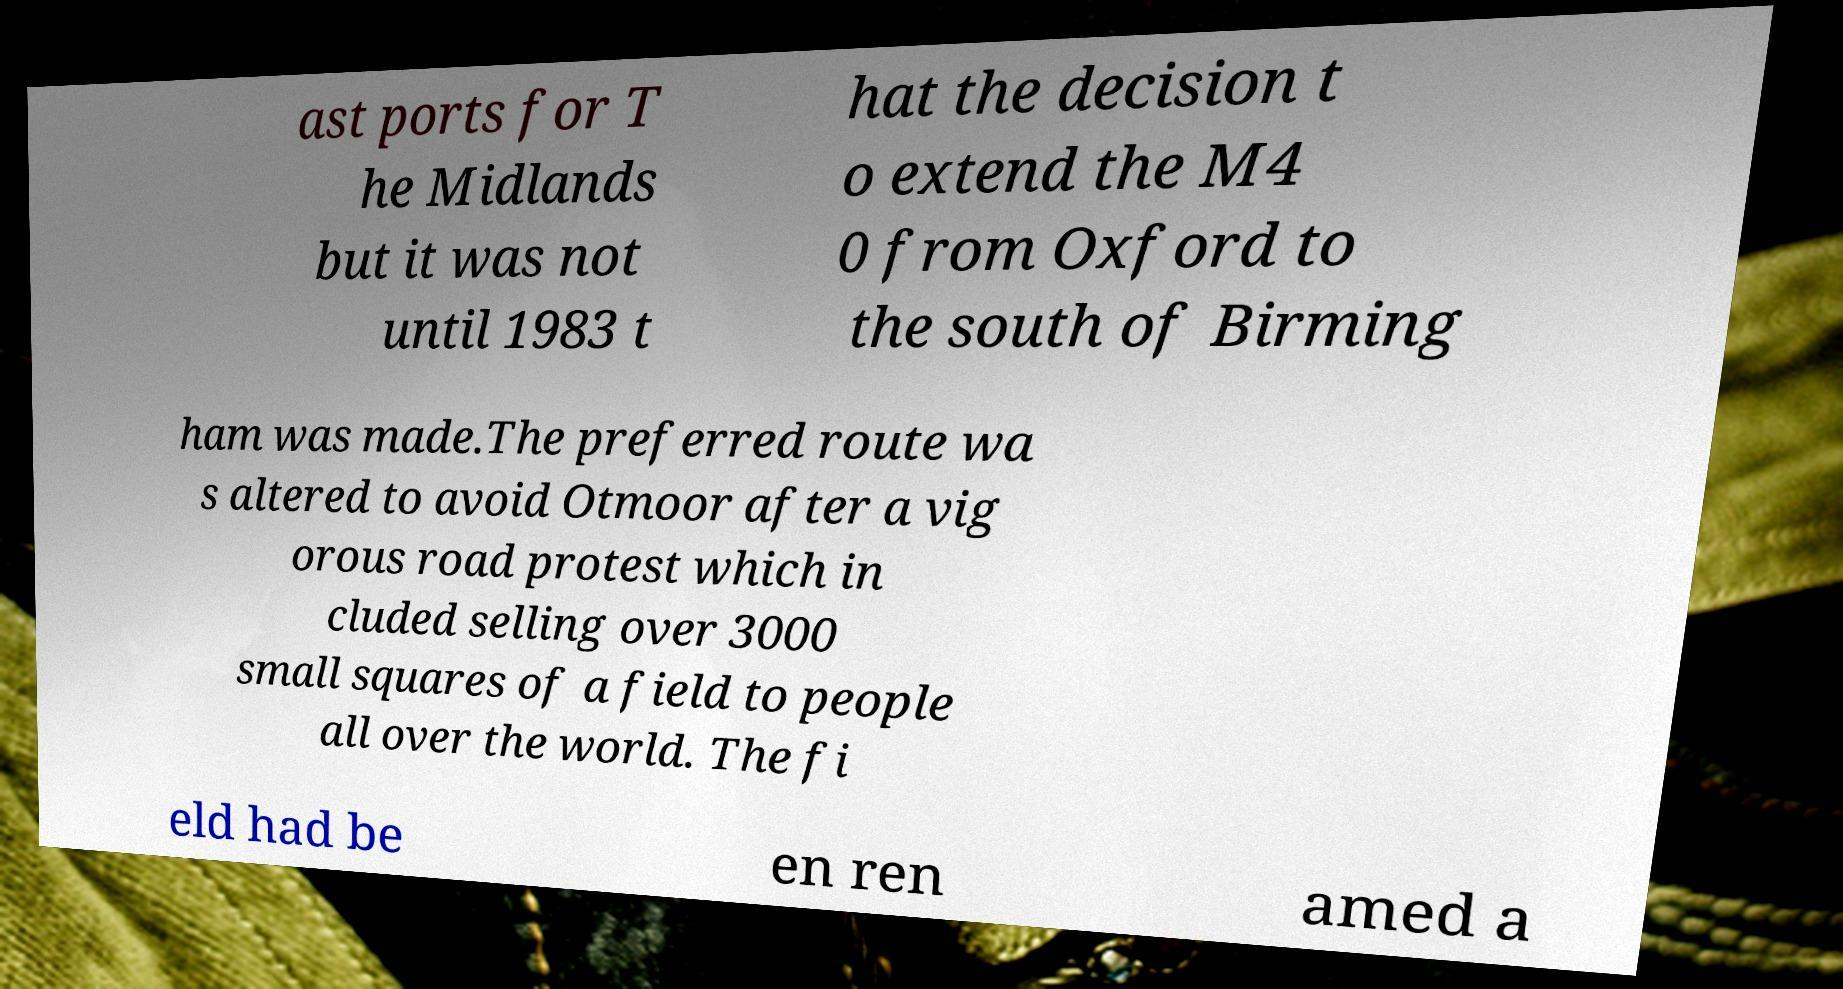There's text embedded in this image that I need extracted. Can you transcribe it verbatim? ast ports for T he Midlands but it was not until 1983 t hat the decision t o extend the M4 0 from Oxford to the south of Birming ham was made.The preferred route wa s altered to avoid Otmoor after a vig orous road protest which in cluded selling over 3000 small squares of a field to people all over the world. The fi eld had be en ren amed a 